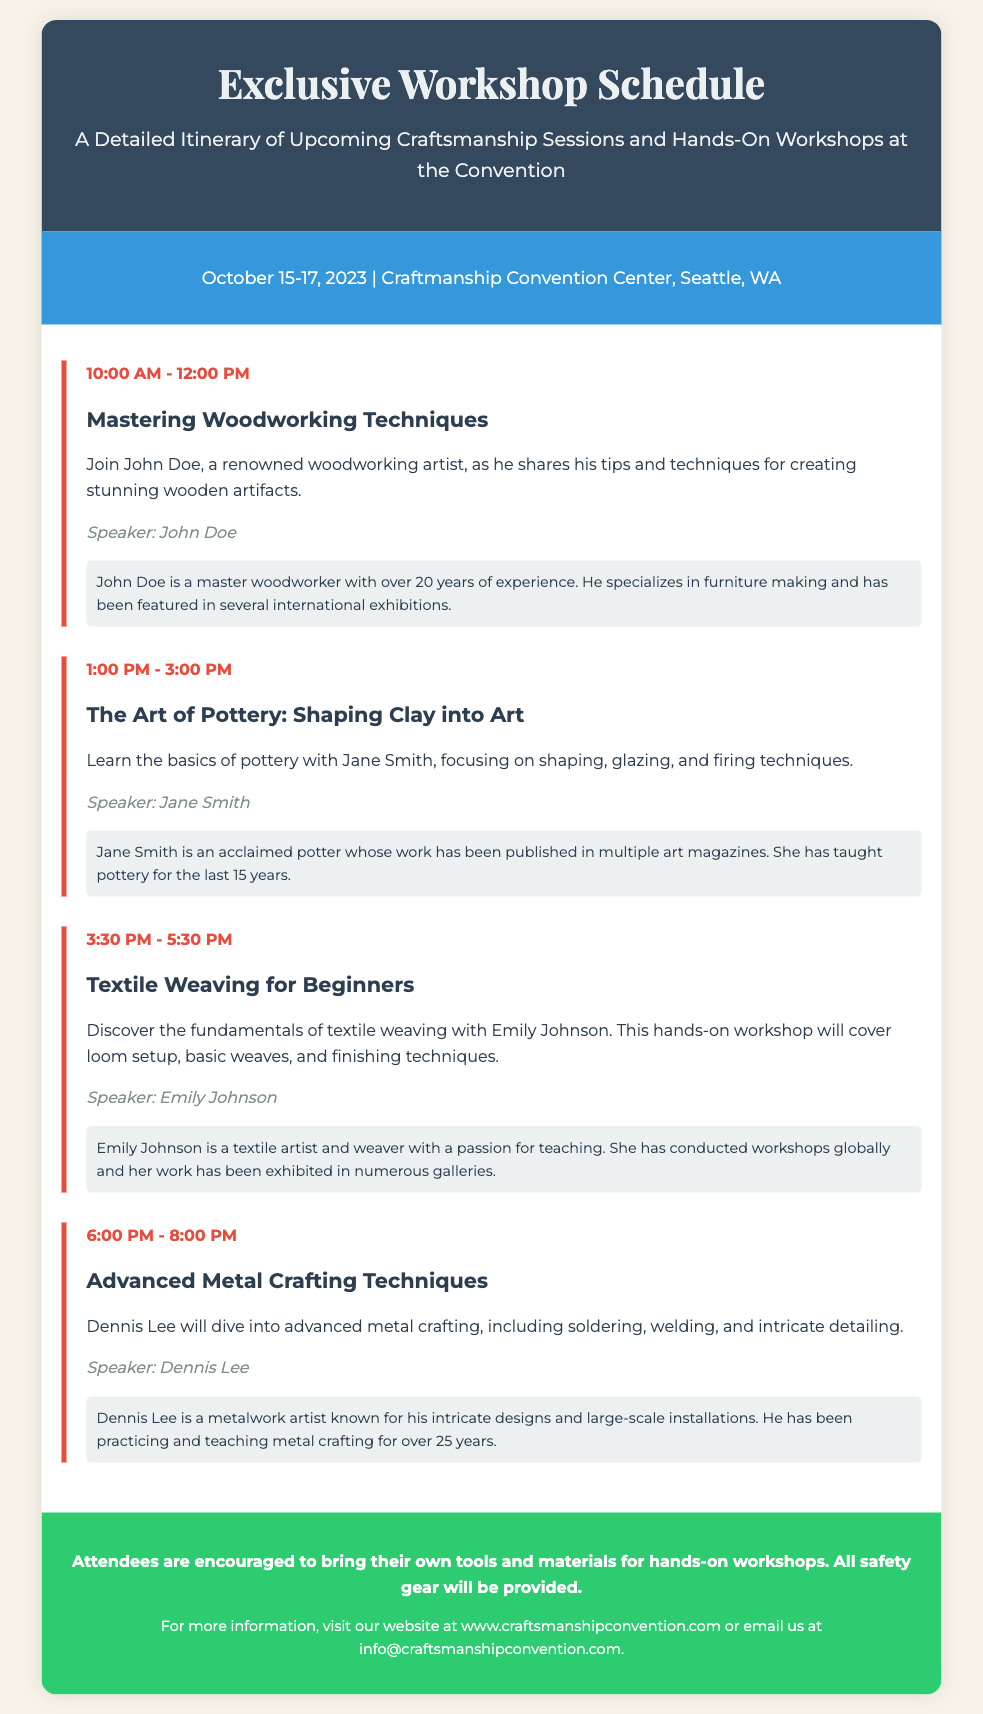What are the dates of the convention? The document states the event is from October 15-17, 2023.
Answer: October 15-17, 2023 Who is the speaker for the "Mastering Woodworking Techniques" session? The document specifies that John Doe is the speaker for this session.
Answer: John Doe What time does the "Textile Weaving for Beginners" workshop start? The document shows that this workshop starts at 3:30 PM.
Answer: 3:30 PM How many years of experience does Dennis Lee have in metal crafting? The document mentions that Dennis Lee has been practicing and teaching for over 25 years.
Answer: 25 years What should attendees bring for the hands-on workshops? The document advises attendees to bring their own tools and materials.
Answer: Tools and materials What type of session is offered at 1:00 PM? The document indicates that a pottery session is scheduled at this time.
Answer: Pottery session Which city is hosting the Craftsmanship Convention? The document states that the convention takes place in Seattle, WA.
Answer: Seattle, WA What color is used for the event details section? The document describes the event details background as blue.
Answer: Blue 